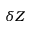<formula> <loc_0><loc_0><loc_500><loc_500>\delta Z</formula> 